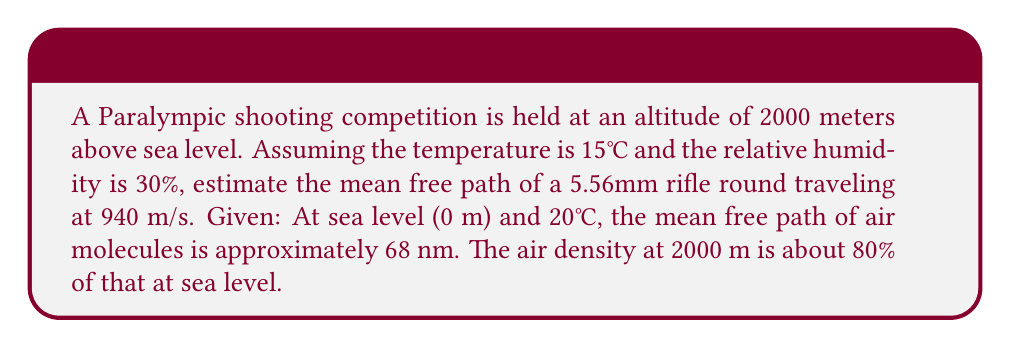Help me with this question. To solve this problem, we'll use the concept of mean free path in statistical mechanics and adjust it for the given conditions:

1) The mean free path ($\lambda$) is inversely proportional to the number density of air molecules ($n$):

   $$\lambda \propto \frac{1}{n}$$

2) At 2000 m, the air density is 80% of that at sea level. This means:

   $$n_{2000m} = 0.8 \times n_{sea level}$$

3) The mean free path at 2000 m ($\lambda_{2000m}$) can be estimated as:

   $$\lambda_{2000m} = \frac{\lambda_{sea level}}{0.8} = \frac{68 \text{ nm}}{0.8} = 85 \text{ nm}$$

4) For a projectile, we need to consider its size relative to air molecules. The mean free path for a large projectile ($\lambda_p$) is approximately:

   $$\lambda_p \approx \frac{4}{3} \frac{d_p^2}{d_m^2} \lambda$$

   where $d_p$ is the diameter of the projectile and $d_m$ is the diameter of air molecules.

5) For a 5.56mm round:
   $d_p = 5.56 \text{ mm} = 5.56 \times 10^6 \text{ nm}$
   $d_m \approx 0.3 \text{ nm}$ (approximate diameter of air molecules)

6) Substituting these values:

   $$\lambda_p \approx \frac{4}{3} \frac{(5.56 \times 10^6 \text{ nm})^2}{(0.3 \text{ nm})^2} \times 85 \text{ nm}$$

7) Calculating:

   $$\lambda_p \approx 7.26 \times 10^{15} \text{ nm} = 7.26 \text{ m}$$

This result represents the average distance the projectile travels before a significant collision with air molecules.
Answer: 7.26 m 